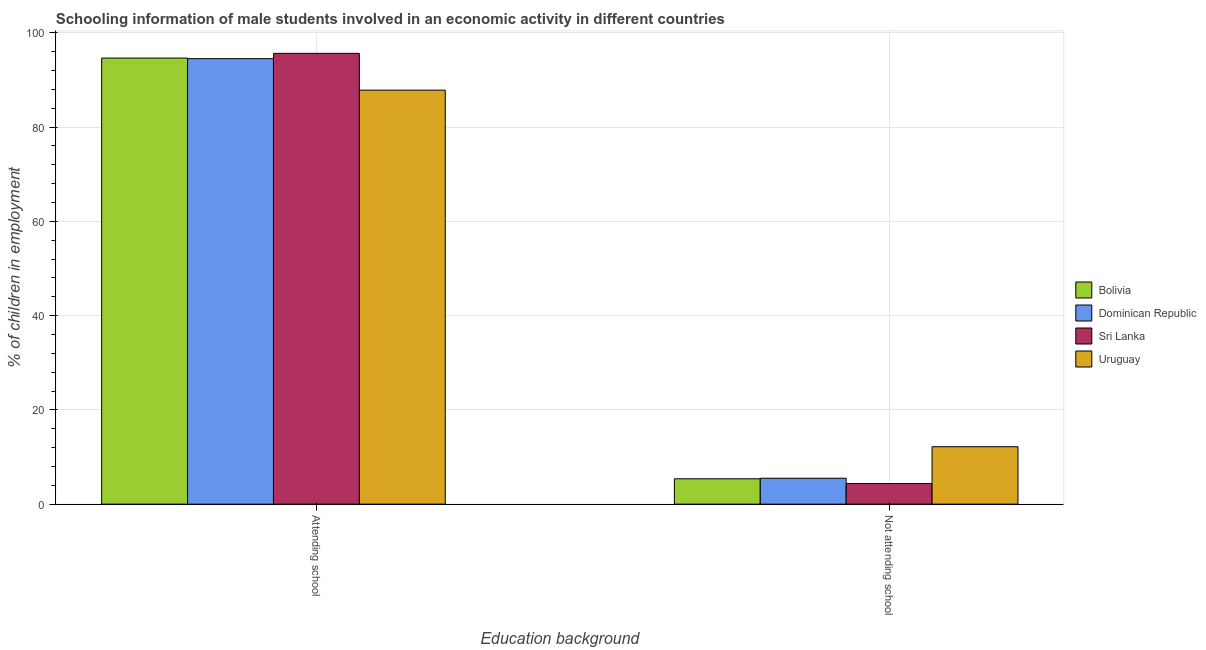How many groups of bars are there?
Provide a succinct answer. 2. Are the number of bars per tick equal to the number of legend labels?
Your response must be concise. Yes. Are the number of bars on each tick of the X-axis equal?
Your response must be concise. Yes. How many bars are there on the 1st tick from the left?
Provide a succinct answer. 4. What is the label of the 2nd group of bars from the left?
Offer a terse response. Not attending school. What is the percentage of employed males who are attending school in Sri Lanka?
Make the answer very short. 95.62. Across all countries, what is the maximum percentage of employed males who are attending school?
Provide a succinct answer. 95.62. Across all countries, what is the minimum percentage of employed males who are not attending school?
Offer a terse response. 4.38. In which country was the percentage of employed males who are attending school maximum?
Give a very brief answer. Sri Lanka. In which country was the percentage of employed males who are not attending school minimum?
Your response must be concise. Sri Lanka. What is the total percentage of employed males who are not attending school in the graph?
Offer a terse response. 27.44. What is the difference between the percentage of employed males who are attending school in Uruguay and that in Dominican Republic?
Your answer should be very brief. -6.68. What is the difference between the percentage of employed males who are not attending school in Dominican Republic and the percentage of employed males who are attending school in Sri Lanka?
Your response must be concise. -90.12. What is the average percentage of employed males who are attending school per country?
Keep it short and to the point. 93.14. What is the difference between the percentage of employed males who are attending school and percentage of employed males who are not attending school in Sri Lanka?
Make the answer very short. 91.24. In how many countries, is the percentage of employed males who are attending school greater than 64 %?
Provide a succinct answer. 4. What is the ratio of the percentage of employed males who are attending school in Sri Lanka to that in Dominican Republic?
Your answer should be compact. 1.01. What does the 4th bar from the left in Not attending school represents?
Your answer should be compact. Uruguay. What does the 2nd bar from the right in Attending school represents?
Ensure brevity in your answer.  Sri Lanka. How many bars are there?
Make the answer very short. 8. Are all the bars in the graph horizontal?
Give a very brief answer. No. Are the values on the major ticks of Y-axis written in scientific E-notation?
Your answer should be compact. No. Does the graph contain any zero values?
Offer a terse response. No. Does the graph contain grids?
Offer a very short reply. Yes. Where does the legend appear in the graph?
Keep it short and to the point. Center right. How many legend labels are there?
Keep it short and to the point. 4. How are the legend labels stacked?
Make the answer very short. Vertical. What is the title of the graph?
Provide a short and direct response. Schooling information of male students involved in an economic activity in different countries. Does "Uruguay" appear as one of the legend labels in the graph?
Provide a succinct answer. Yes. What is the label or title of the X-axis?
Offer a terse response. Education background. What is the label or title of the Y-axis?
Provide a short and direct response. % of children in employment. What is the % of children in employment of Bolivia in Attending school?
Give a very brief answer. 94.62. What is the % of children in employment of Dominican Republic in Attending school?
Your response must be concise. 94.5. What is the % of children in employment in Sri Lanka in Attending school?
Provide a succinct answer. 95.62. What is the % of children in employment of Uruguay in Attending school?
Provide a succinct answer. 87.82. What is the % of children in employment in Bolivia in Not attending school?
Provide a short and direct response. 5.38. What is the % of children in employment in Dominican Republic in Not attending school?
Ensure brevity in your answer.  5.5. What is the % of children in employment in Sri Lanka in Not attending school?
Ensure brevity in your answer.  4.38. What is the % of children in employment of Uruguay in Not attending school?
Provide a short and direct response. 12.18. Across all Education background, what is the maximum % of children in employment of Bolivia?
Your response must be concise. 94.62. Across all Education background, what is the maximum % of children in employment in Dominican Republic?
Provide a short and direct response. 94.5. Across all Education background, what is the maximum % of children in employment of Sri Lanka?
Your answer should be very brief. 95.62. Across all Education background, what is the maximum % of children in employment of Uruguay?
Ensure brevity in your answer.  87.82. Across all Education background, what is the minimum % of children in employment of Bolivia?
Give a very brief answer. 5.38. Across all Education background, what is the minimum % of children in employment in Sri Lanka?
Make the answer very short. 4.38. Across all Education background, what is the minimum % of children in employment of Uruguay?
Your response must be concise. 12.18. What is the total % of children in employment of Bolivia in the graph?
Ensure brevity in your answer.  100. What is the total % of children in employment in Sri Lanka in the graph?
Provide a short and direct response. 100. What is the total % of children in employment of Uruguay in the graph?
Provide a short and direct response. 100. What is the difference between the % of children in employment of Bolivia in Attending school and that in Not attending school?
Ensure brevity in your answer.  89.24. What is the difference between the % of children in employment of Dominican Republic in Attending school and that in Not attending school?
Offer a very short reply. 89. What is the difference between the % of children in employment of Sri Lanka in Attending school and that in Not attending school?
Give a very brief answer. 91.24. What is the difference between the % of children in employment of Uruguay in Attending school and that in Not attending school?
Your answer should be very brief. 75.64. What is the difference between the % of children in employment in Bolivia in Attending school and the % of children in employment in Dominican Republic in Not attending school?
Ensure brevity in your answer.  89.12. What is the difference between the % of children in employment of Bolivia in Attending school and the % of children in employment of Sri Lanka in Not attending school?
Your response must be concise. 90.24. What is the difference between the % of children in employment of Bolivia in Attending school and the % of children in employment of Uruguay in Not attending school?
Give a very brief answer. 82.44. What is the difference between the % of children in employment of Dominican Republic in Attending school and the % of children in employment of Sri Lanka in Not attending school?
Provide a succinct answer. 90.12. What is the difference between the % of children in employment of Dominican Republic in Attending school and the % of children in employment of Uruguay in Not attending school?
Offer a terse response. 82.32. What is the difference between the % of children in employment in Sri Lanka in Attending school and the % of children in employment in Uruguay in Not attending school?
Ensure brevity in your answer.  83.44. What is the average % of children in employment of Uruguay per Education background?
Provide a short and direct response. 50. What is the difference between the % of children in employment of Bolivia and % of children in employment of Dominican Republic in Attending school?
Ensure brevity in your answer.  0.12. What is the difference between the % of children in employment in Bolivia and % of children in employment in Sri Lanka in Attending school?
Give a very brief answer. -1. What is the difference between the % of children in employment in Bolivia and % of children in employment in Uruguay in Attending school?
Your response must be concise. 6.8. What is the difference between the % of children in employment in Dominican Republic and % of children in employment in Sri Lanka in Attending school?
Keep it short and to the point. -1.12. What is the difference between the % of children in employment in Dominican Republic and % of children in employment in Uruguay in Attending school?
Provide a short and direct response. 6.68. What is the difference between the % of children in employment in Sri Lanka and % of children in employment in Uruguay in Attending school?
Provide a succinct answer. 7.8. What is the difference between the % of children in employment of Bolivia and % of children in employment of Dominican Republic in Not attending school?
Provide a succinct answer. -0.12. What is the difference between the % of children in employment of Bolivia and % of children in employment of Uruguay in Not attending school?
Offer a very short reply. -6.8. What is the difference between the % of children in employment in Dominican Republic and % of children in employment in Sri Lanka in Not attending school?
Your answer should be very brief. 1.12. What is the difference between the % of children in employment of Dominican Republic and % of children in employment of Uruguay in Not attending school?
Keep it short and to the point. -6.68. What is the difference between the % of children in employment in Sri Lanka and % of children in employment in Uruguay in Not attending school?
Ensure brevity in your answer.  -7.8. What is the ratio of the % of children in employment of Bolivia in Attending school to that in Not attending school?
Your response must be concise. 17.59. What is the ratio of the % of children in employment of Dominican Republic in Attending school to that in Not attending school?
Provide a succinct answer. 17.18. What is the ratio of the % of children in employment of Sri Lanka in Attending school to that in Not attending school?
Offer a very short reply. 21.84. What is the ratio of the % of children in employment in Uruguay in Attending school to that in Not attending school?
Your answer should be compact. 7.21. What is the difference between the highest and the second highest % of children in employment of Bolivia?
Your answer should be very brief. 89.24. What is the difference between the highest and the second highest % of children in employment of Dominican Republic?
Your answer should be very brief. 89. What is the difference between the highest and the second highest % of children in employment of Sri Lanka?
Your answer should be compact. 91.24. What is the difference between the highest and the second highest % of children in employment in Uruguay?
Ensure brevity in your answer.  75.64. What is the difference between the highest and the lowest % of children in employment in Bolivia?
Provide a short and direct response. 89.24. What is the difference between the highest and the lowest % of children in employment of Dominican Republic?
Give a very brief answer. 89. What is the difference between the highest and the lowest % of children in employment of Sri Lanka?
Your answer should be very brief. 91.24. What is the difference between the highest and the lowest % of children in employment of Uruguay?
Offer a very short reply. 75.64. 